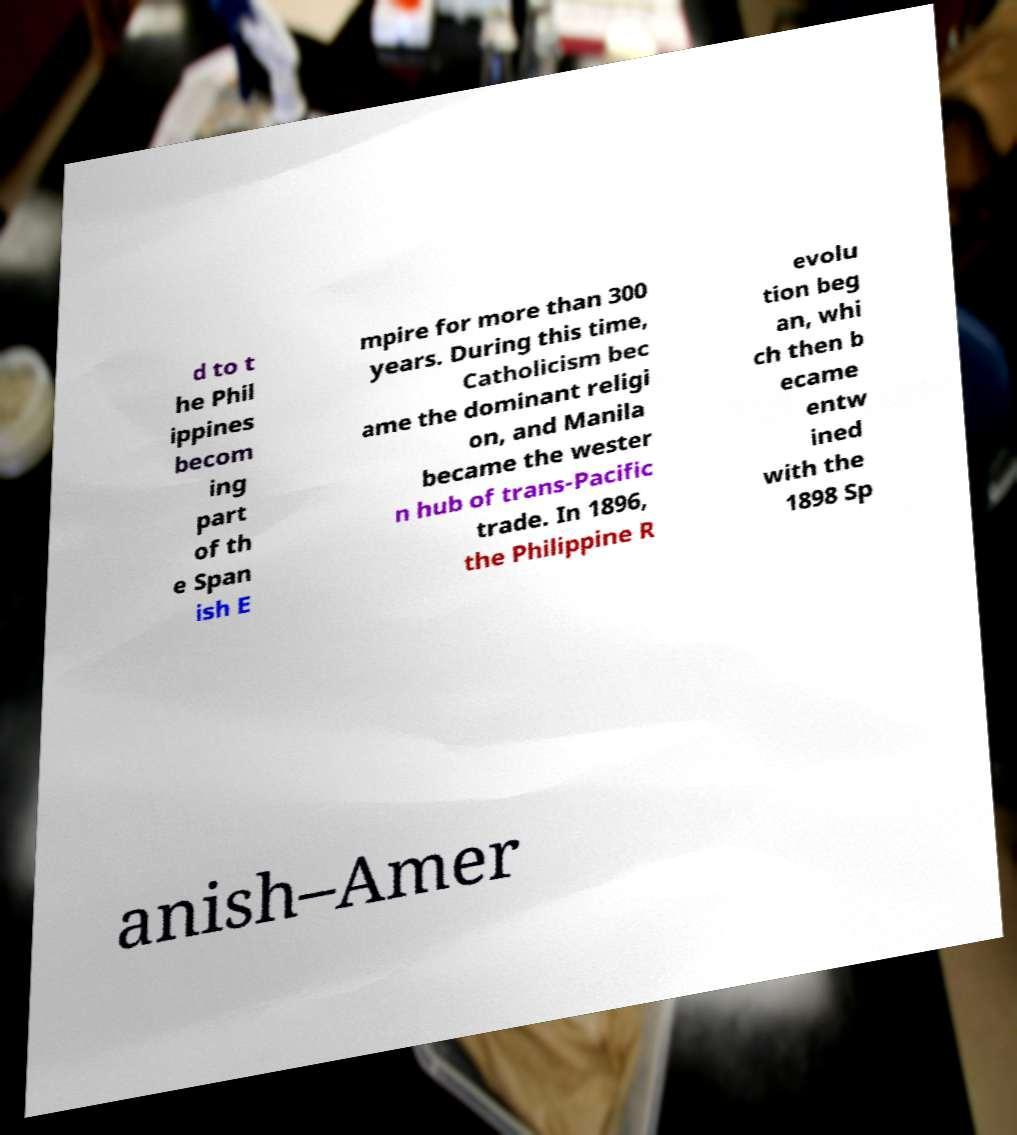Can you read and provide the text displayed in the image?This photo seems to have some interesting text. Can you extract and type it out for me? d to t he Phil ippines becom ing part of th e Span ish E mpire for more than 300 years. During this time, Catholicism bec ame the dominant religi on, and Manila became the wester n hub of trans-Pacific trade. In 1896, the Philippine R evolu tion beg an, whi ch then b ecame entw ined with the 1898 Sp anish–Amer 